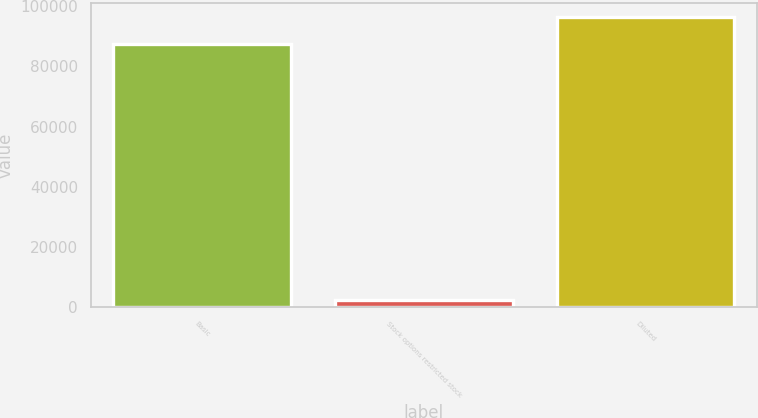<chart> <loc_0><loc_0><loc_500><loc_500><bar_chart><fcel>Basic<fcel>Stock options restricted stock<fcel>Diluted<nl><fcel>87499<fcel>2324<fcel>96248.9<nl></chart> 